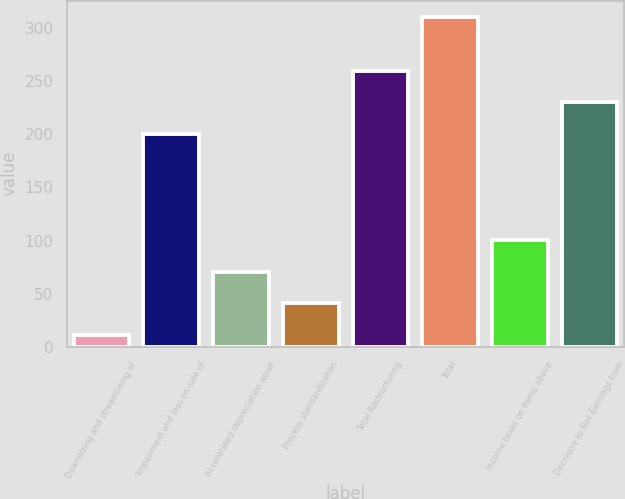Convert chart to OTSL. <chart><loc_0><loc_0><loc_500><loc_500><bar_chart><fcel>Downsizing and streamlining of<fcel>Impairment and loss on sale of<fcel>Accelerated depreciation asset<fcel>Process standardization<fcel>Total Restructuring<fcel>Total<fcel>Income taxes on items above<fcel>Decrease to Net Earnings from<nl><fcel>11<fcel>200<fcel>70.8<fcel>40.9<fcel>259.8<fcel>310<fcel>100.7<fcel>229.9<nl></chart> 